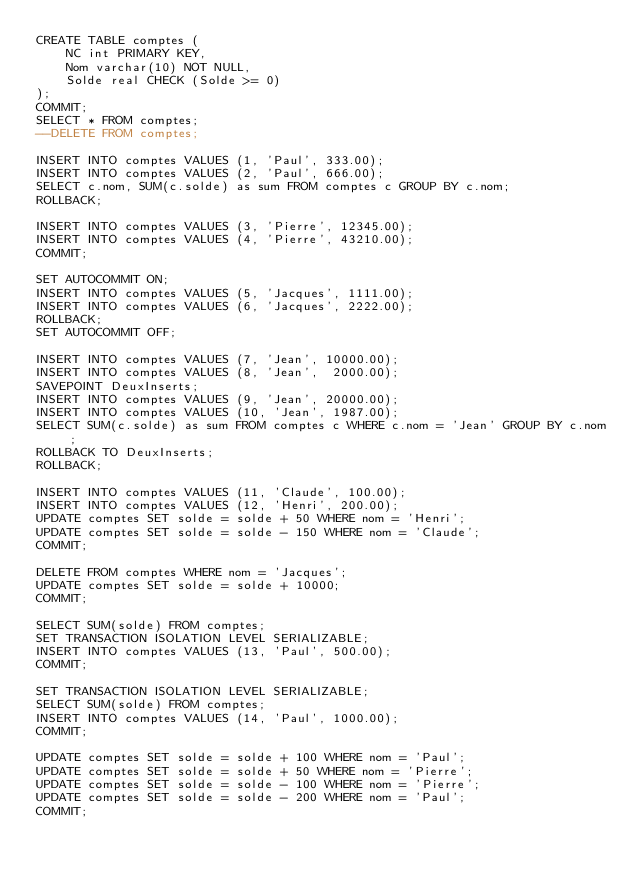Convert code to text. <code><loc_0><loc_0><loc_500><loc_500><_SQL_>CREATE TABLE comptes (
    NC int PRIMARY KEY,
    Nom varchar(10) NOT NULL,
    Solde real CHECK (Solde >= 0)
);
COMMIT;
SELECT * FROM comptes;
--DELETE FROM comptes;

INSERT INTO comptes VALUES (1, 'Paul', 333.00);
INSERT INTO comptes VALUES (2, 'Paul', 666.00);
SELECT c.nom, SUM(c.solde) as sum FROM comptes c GROUP BY c.nom;
ROLLBACK;

INSERT INTO comptes VALUES (3, 'Pierre', 12345.00);
INSERT INTO comptes VALUES (4, 'Pierre', 43210.00);
COMMIT;

SET AUTOCOMMIT ON;
INSERT INTO comptes VALUES (5, 'Jacques', 1111.00);
INSERT INTO comptes VALUES (6, 'Jacques', 2222.00);
ROLLBACK;
SET AUTOCOMMIT OFF;

INSERT INTO comptes VALUES (7, 'Jean', 10000.00);
INSERT INTO comptes VALUES (8, 'Jean',  2000.00);
SAVEPOINT DeuxInserts;
INSERT INTO comptes VALUES (9, 'Jean', 20000.00);
INSERT INTO comptes VALUES (10, 'Jean', 1987.00);
SELECT SUM(c.solde) as sum FROM comptes c WHERE c.nom = 'Jean' GROUP BY c.nom;
ROLLBACK TO DeuxInserts;
ROLLBACK;

INSERT INTO comptes VALUES (11, 'Claude', 100.00);
INSERT INTO comptes VALUES (12, 'Henri', 200.00);
UPDATE comptes SET solde = solde + 50 WHERE nom = 'Henri';
UPDATE comptes SET solde = solde - 150 WHERE nom = 'Claude';
COMMIT;

DELETE FROM comptes WHERE nom = 'Jacques';
UPDATE comptes SET solde = solde + 10000;
COMMIT;

SELECT SUM(solde) FROM comptes;
SET TRANSACTION ISOLATION LEVEL SERIALIZABLE;
INSERT INTO comptes VALUES (13, 'Paul', 500.00);
COMMIT;

SET TRANSACTION ISOLATION LEVEL SERIALIZABLE;
SELECT SUM(solde) FROM comptes;
INSERT INTO comptes VALUES (14, 'Paul', 1000.00);
COMMIT;

UPDATE comptes SET solde = solde + 100 WHERE nom = 'Paul';
UPDATE comptes SET solde = solde + 50 WHERE nom = 'Pierre';
UPDATE comptes SET solde = solde - 100 WHERE nom = 'Pierre';
UPDATE comptes SET solde = solde - 200 WHERE nom = 'Paul';
COMMIT;
</code> 